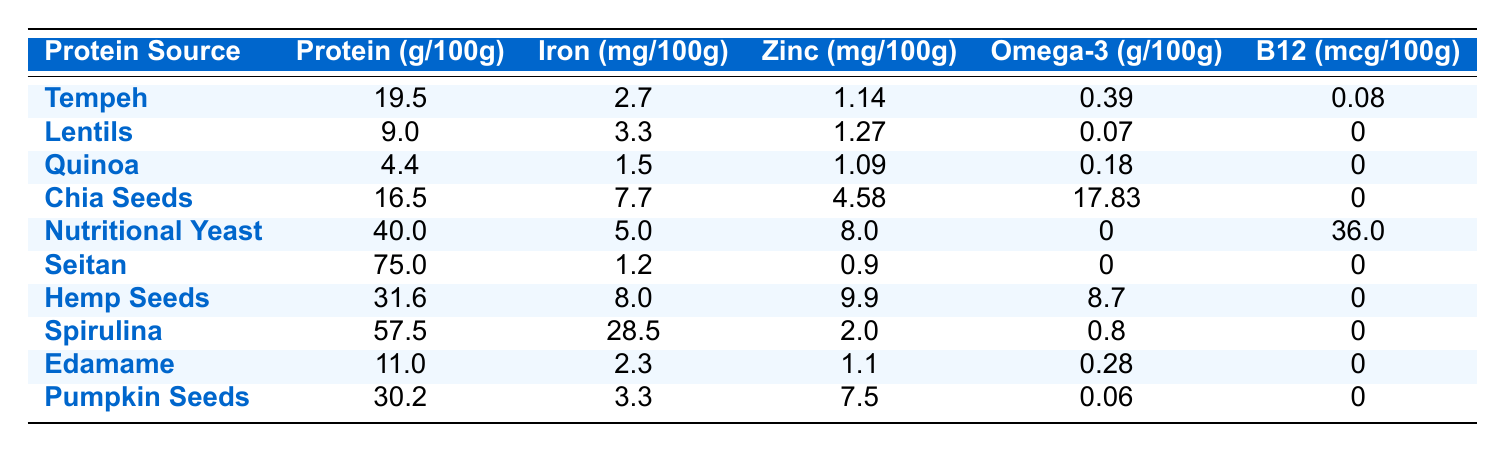What is the protein content of Seitan per 100g? The table indicates that Seitan contains 75.0g of protein for every 100g.
Answer: 75.0g Which protein source has the highest iron content? By reviewing the "Iron (mg/100g)" column, Spirulina has the highest value at 28.5mg.
Answer: Spirulina Calculate the average protein content of Chia Seeds and Hemp Seeds. For Chia Seeds, the protein content is 16.5g, and for Hemp Seeds, it is 31.6g. The average is (16.5 + 31.6) / 2 = 24.05g.
Answer: 24.05g Is Nutritional Yeast a good source of Vitamin B12? Yes, the table shows that Nutritional Yeast contains 36.0mcg of Vitamin B12 per 100g, which is a significant amount.
Answer: Yes How much more zinc does Hemp Seeds have compared to Edamame? Hemp Seeds have 9.9mg of zinc while Edamame has 1.1mg. The difference is 9.9 - 1.1 = 8.8mg.
Answer: 8.8mg Which two protein sources together would provide more than 50 grams of protein per 100 grams? Seitan (75.0g) and Spirulina (57.5g) both have high protein content. However, they overlap by calculation when summed: 75.0 + 57.5 = 132.5g, which is more than 50 grams.
Answer: Seitan and Spirulina What is the protein content of Lentils relative to the average protein content of all protein sources listed? First, we sum all protein values: (19.5 + 9.0 + 4.4 + 16.5 + 40.0 + 75.0 + 31.6 + 57.5 + 11.0 + 30.2) = 364.7g. Divide by 10 (number of sources) gives us an average of 36.47g. Compared to that, Lentils has 9.0g, which is significantly lower.
Answer: Lower than average Do Chia Seeds provide more Omega-3 than any other source listed? The table reveals that Chia Seeds contain 17.83g of Omega-3, which is greater than all other entries.
Answer: Yes What is the total protein content of the two highest protein sources? Seitan has 75.0g and Spirulina has 57.5g. Their total is 75.0 + 57.5 = 132.5g.
Answer: 132.5g 